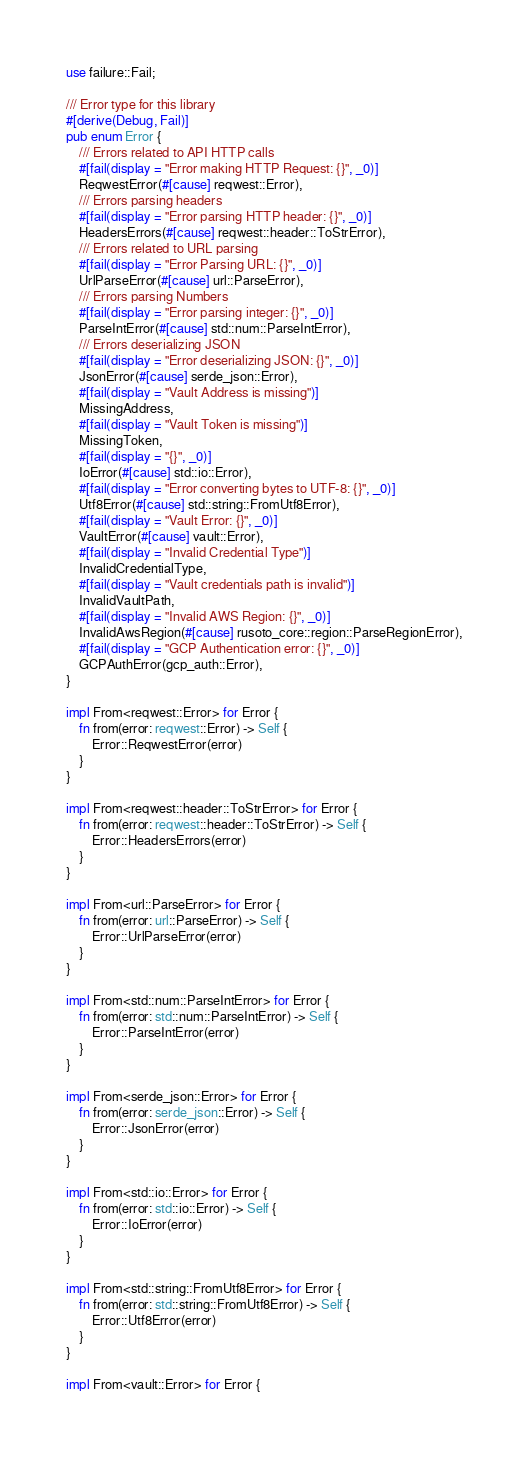Convert code to text. <code><loc_0><loc_0><loc_500><loc_500><_Rust_>use failure::Fail;

/// Error type for this library
#[derive(Debug, Fail)]
pub enum Error {
    /// Errors related to API HTTP calls
    #[fail(display = "Error making HTTP Request: {}", _0)]
    ReqwestError(#[cause] reqwest::Error),
    /// Errors parsing headers
    #[fail(display = "Error parsing HTTP header: {}", _0)]
    HeadersErrors(#[cause] reqwest::header::ToStrError),
    /// Errors related to URL parsing
    #[fail(display = "Error Parsing URL: {}", _0)]
    UrlParseError(#[cause] url::ParseError),
    /// Errors parsing Numbers
    #[fail(display = "Error parsing integer: {}", _0)]
    ParseIntError(#[cause] std::num::ParseIntError),
    /// Errors deserializing JSON
    #[fail(display = "Error deserializing JSON: {}", _0)]
    JsonError(#[cause] serde_json::Error),
    #[fail(display = "Vault Address is missing")]
    MissingAddress,
    #[fail(display = "Vault Token is missing")]
    MissingToken,
    #[fail(display = "{}", _0)]
    IoError(#[cause] std::io::Error),
    #[fail(display = "Error converting bytes to UTF-8: {}", _0)]
    Utf8Error(#[cause] std::string::FromUtf8Error),
    #[fail(display = "Vault Error: {}", _0)]
    VaultError(#[cause] vault::Error),
    #[fail(display = "Invalid Credential Type")]
    InvalidCredentialType,
    #[fail(display = "Vault credentials path is invalid")]
    InvalidVaultPath,
    #[fail(display = "Invalid AWS Region: {}", _0)]
    InvalidAwsRegion(#[cause] rusoto_core::region::ParseRegionError),
    #[fail(display = "GCP Authentication error: {}", _0)]
    GCPAuthError(gcp_auth::Error),
}

impl From<reqwest::Error> for Error {
    fn from(error: reqwest::Error) -> Self {
        Error::ReqwestError(error)
    }
}

impl From<reqwest::header::ToStrError> for Error {
    fn from(error: reqwest::header::ToStrError) -> Self {
        Error::HeadersErrors(error)
    }
}

impl From<url::ParseError> for Error {
    fn from(error: url::ParseError) -> Self {
        Error::UrlParseError(error)
    }
}

impl From<std::num::ParseIntError> for Error {
    fn from(error: std::num::ParseIntError) -> Self {
        Error::ParseIntError(error)
    }
}

impl From<serde_json::Error> for Error {
    fn from(error: serde_json::Error) -> Self {
        Error::JsonError(error)
    }
}

impl From<std::io::Error> for Error {
    fn from(error: std::io::Error) -> Self {
        Error::IoError(error)
    }
}

impl From<std::string::FromUtf8Error> for Error {
    fn from(error: std::string::FromUtf8Error) -> Self {
        Error::Utf8Error(error)
    }
}

impl From<vault::Error> for Error {</code> 